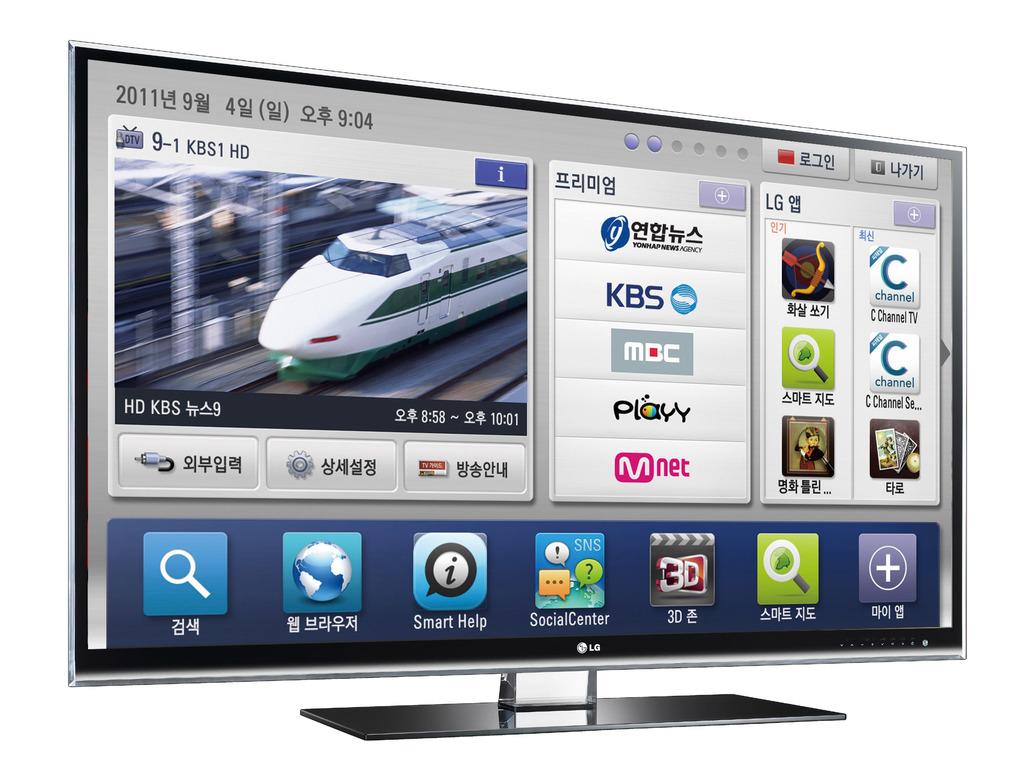The middle column, second name is kbs?
Provide a succinct answer. Yes. 